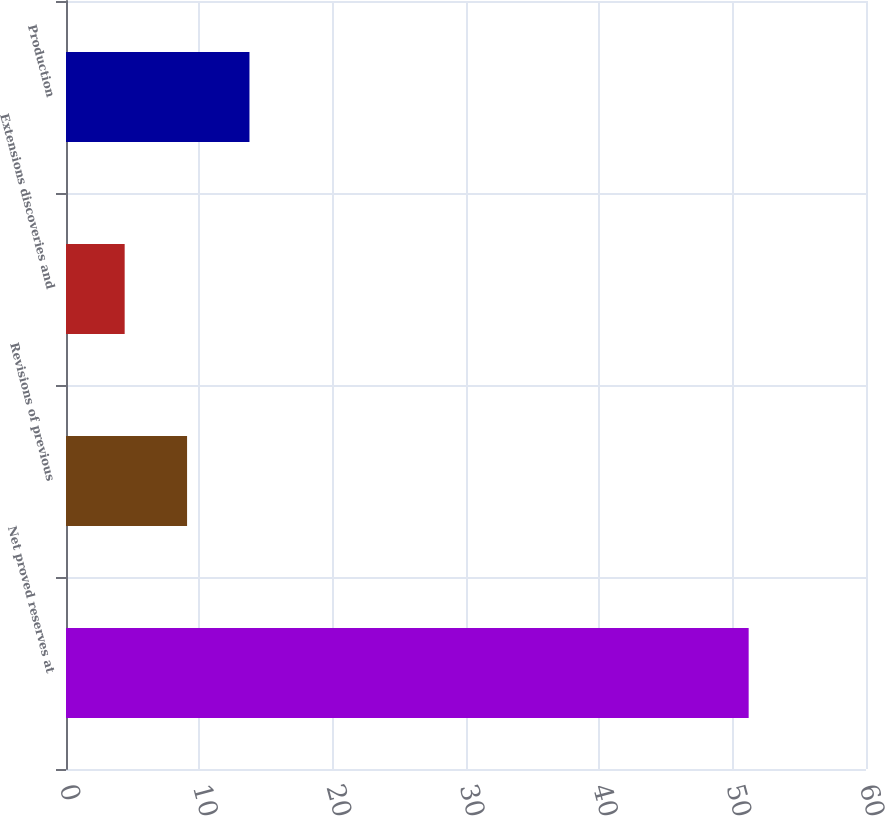Convert chart to OTSL. <chart><loc_0><loc_0><loc_500><loc_500><bar_chart><fcel>Net proved reserves at<fcel>Revisions of previous<fcel>Extensions discoveries and<fcel>Production<nl><fcel>51.2<fcel>9.08<fcel>4.4<fcel>13.76<nl></chart> 